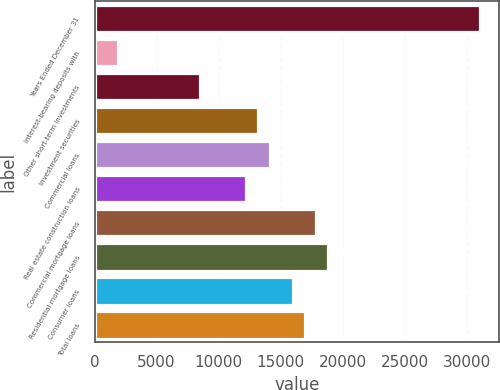<chart> <loc_0><loc_0><loc_500><loc_500><bar_chart><fcel>Years Ended December 31<fcel>Interest-bearing deposits with<fcel>Other short-term investments<fcel>Investment securities<fcel>Commercial loans<fcel>Real estate construction loans<fcel>Commercial mortgage loans<fcel>Residential mortgage loans<fcel>Consumer loans<fcel>Total loans<nl><fcel>31026.6<fcel>1880.43<fcel>8461.83<fcel>13162.8<fcel>14103<fcel>12222.6<fcel>17863.8<fcel>18804<fcel>15983.4<fcel>16923.6<nl></chart> 